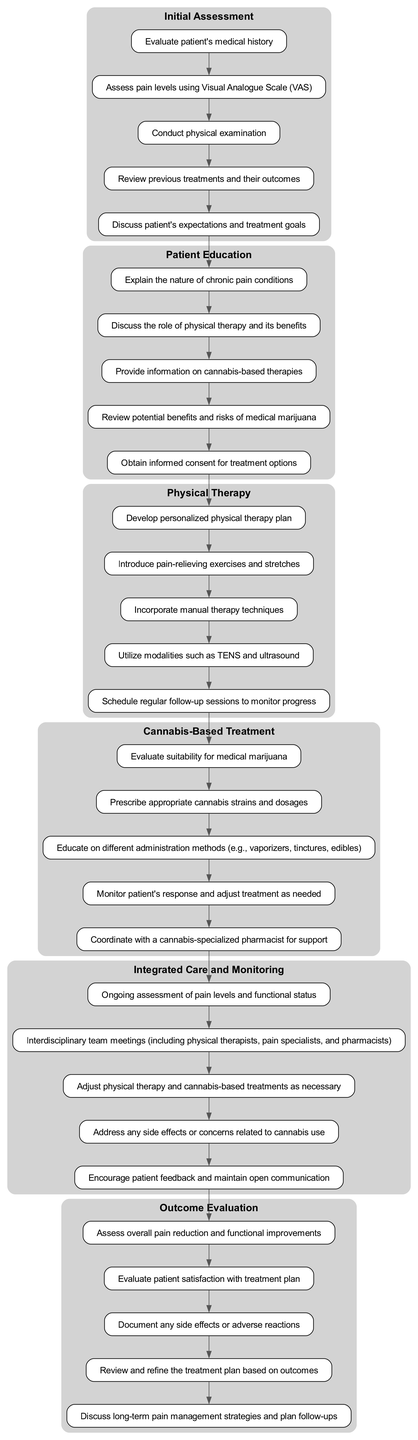What is the first phase in the pathway? The first phase is typically listed as 'Initial Assessment' in the diagram representing the clinical pathway.
Answer: Initial Assessment How many steps are in the 'Patient Education' phase? Counting the steps listed under the 'Patient Education' phase shows there are five distinct steps.
Answer: 5 What is the last step in the 'Cannabis-Based Treatment' phase? The last step is to coordinate with a cannabis-specialized pharmacist for support, which indicates collaboration for optimized care.
Answer: Coordinate with a cannabis-specialized pharmacist for support What connects the 'Physical Therapy' phase and the 'Cannabis-Based Treatment' phase? The connection between these phases is established through the last step of 'Physical Therapy', which leads directly into the first step of 'Cannabis-Based Treatment'.
Answer: Last step of 'Physical Therapy' Which phase has the most steps? By comparing the number of steps across all phases, we can conclude that the 'Integrated Care and Monitoring' phase has the most steps, with a total of five.
Answer: Integrated Care and Monitoring During which phase is informed consent obtained? The step regarding obtaining informed consent is clearly mentioned under the 'Patient Education' phase, indicating the importance of patient awareness prior to treatment.
Answer: Patient Education How many interdisciplinary team meetings are included in the 'Integrated Care and Monitoring' phase? The 'Integrated Care and Monitoring' phase explicitly states there are interdisciplinary team meetings as part of its steps, indicating active collaboration.
Answer: Interdisciplinary team meetings What is assessed in the 'Outcome Evaluation' phase? The 'Outcome Evaluation' phase includes assessing overall pain reduction and functional improvements as its primary focuses for determining treatment efficacy.
Answer: Overall pain reduction and functional improvements 